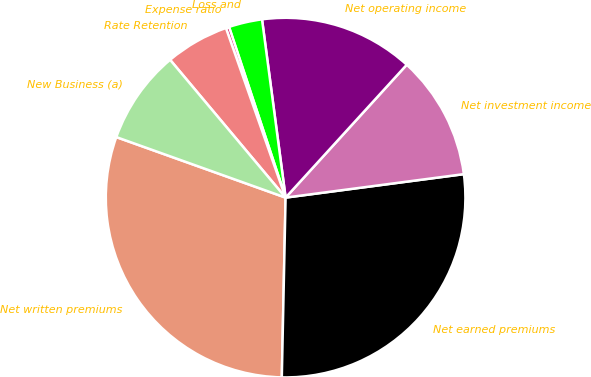<chart> <loc_0><loc_0><loc_500><loc_500><pie_chart><fcel>Net written premiums<fcel>Net earned premiums<fcel>Net investment income<fcel>Net operating income<fcel>Loss and<fcel>Expense ratio<fcel>Rate Retention<fcel>New Business (a)<nl><fcel>30.13%<fcel>27.42%<fcel>11.15%<fcel>13.86%<fcel>3.0%<fcel>0.29%<fcel>5.72%<fcel>8.43%<nl></chart> 